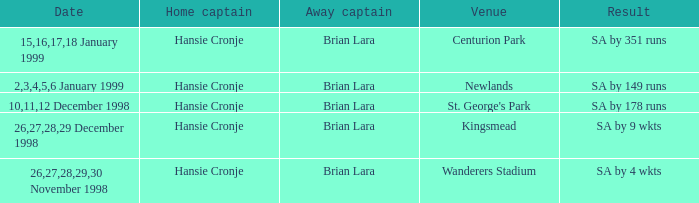Who is the away captain for Kingsmead? Brian Lara. Would you mind parsing the complete table? {'header': ['Date', 'Home captain', 'Away captain', 'Venue', 'Result'], 'rows': [['15,16,17,18 January 1999', 'Hansie Cronje', 'Brian Lara', 'Centurion Park', 'SA by 351 runs'], ['2,3,4,5,6 January 1999', 'Hansie Cronje', 'Brian Lara', 'Newlands', 'SA by 149 runs'], ['10,11,12 December 1998', 'Hansie Cronje', 'Brian Lara', "St. George's Park", 'SA by 178 runs'], ['26,27,28,29 December 1998', 'Hansie Cronje', 'Brian Lara', 'Kingsmead', 'SA by 9 wkts'], ['26,27,28,29,30 November 1998', 'Hansie Cronje', 'Brian Lara', 'Wanderers Stadium', 'SA by 4 wkts']]} 